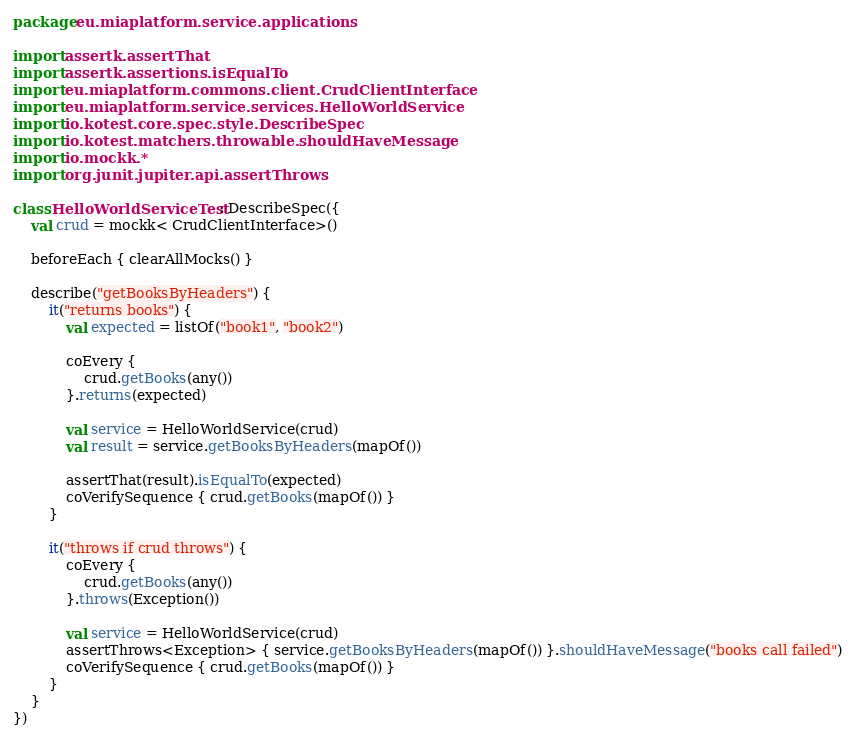<code> <loc_0><loc_0><loc_500><loc_500><_Kotlin_>package eu.miaplatform.service.applications

import assertk.assertThat
import assertk.assertions.isEqualTo
import eu.miaplatform.commons.client.CrudClientInterface
import eu.miaplatform.service.services.HelloWorldService
import io.kotest.core.spec.style.DescribeSpec
import io.kotest.matchers.throwable.shouldHaveMessage
import io.mockk.*
import org.junit.jupiter.api.assertThrows

class HelloWorldServiceTest : DescribeSpec({
    val crud = mockk< CrudClientInterface>()

    beforeEach { clearAllMocks() }

    describe("getBooksByHeaders") {
        it("returns books") {
            val expected = listOf("book1", "book2")

            coEvery {
                crud.getBooks(any())
            }.returns(expected)

            val service = HelloWorldService(crud)
            val result = service.getBooksByHeaders(mapOf())

            assertThat(result).isEqualTo(expected)
            coVerifySequence { crud.getBooks(mapOf()) }
        }

        it("throws if crud throws") {
            coEvery {
                crud.getBooks(any())
            }.throws(Exception())

            val service = HelloWorldService(crud)
            assertThrows<Exception> { service.getBooksByHeaders(mapOf()) }.shouldHaveMessage("books call failed")
            coVerifySequence { crud.getBooks(mapOf()) }
        }
    }
})</code> 